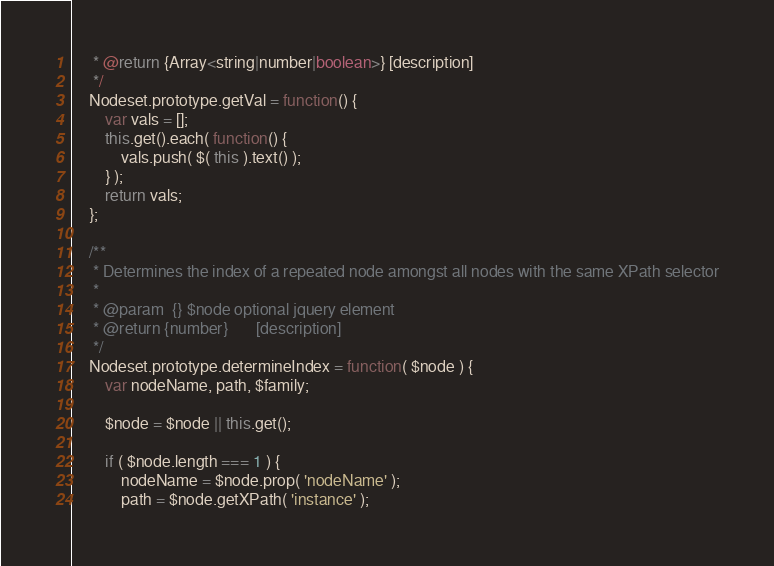<code> <loc_0><loc_0><loc_500><loc_500><_JavaScript_>     * @return {Array<string|number|boolean>} [description]
     */
    Nodeset.prototype.getVal = function() {
        var vals = [];
        this.get().each( function() {
            vals.push( $( this ).text() );
        } );
        return vals;
    };

    /**
     * Determines the index of a repeated node amongst all nodes with the same XPath selector
     *
     * @param  {} $node optional jquery element
     * @return {number}       [description]
     */
    Nodeset.prototype.determineIndex = function( $node ) {
        var nodeName, path, $family;

        $node = $node || this.get();

        if ( $node.length === 1 ) {
            nodeName = $node.prop( 'nodeName' );
            path = $node.getXPath( 'instance' );</code> 